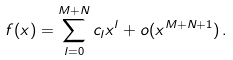Convert formula to latex. <formula><loc_0><loc_0><loc_500><loc_500>f ( x ) = \sum _ { l = 0 } ^ { M + N } c _ { l } x ^ { l } + o ( x ^ { M + N + 1 } ) \, .</formula> 